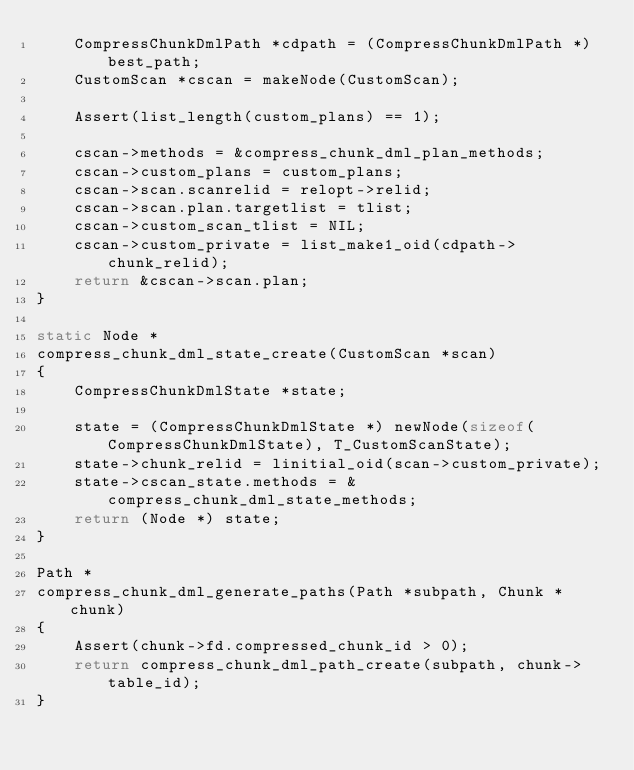Convert code to text. <code><loc_0><loc_0><loc_500><loc_500><_C_>	CompressChunkDmlPath *cdpath = (CompressChunkDmlPath *) best_path;
	CustomScan *cscan = makeNode(CustomScan);

	Assert(list_length(custom_plans) == 1);

	cscan->methods = &compress_chunk_dml_plan_methods;
	cscan->custom_plans = custom_plans;
	cscan->scan.scanrelid = relopt->relid;
	cscan->scan.plan.targetlist = tlist;
	cscan->custom_scan_tlist = NIL;
	cscan->custom_private = list_make1_oid(cdpath->chunk_relid);
	return &cscan->scan.plan;
}

static Node *
compress_chunk_dml_state_create(CustomScan *scan)
{
	CompressChunkDmlState *state;

	state = (CompressChunkDmlState *) newNode(sizeof(CompressChunkDmlState), T_CustomScanState);
	state->chunk_relid = linitial_oid(scan->custom_private);
	state->cscan_state.methods = &compress_chunk_dml_state_methods;
	return (Node *) state;
}

Path *
compress_chunk_dml_generate_paths(Path *subpath, Chunk *chunk)
{
	Assert(chunk->fd.compressed_chunk_id > 0);
	return compress_chunk_dml_path_create(subpath, chunk->table_id);
}
</code> 